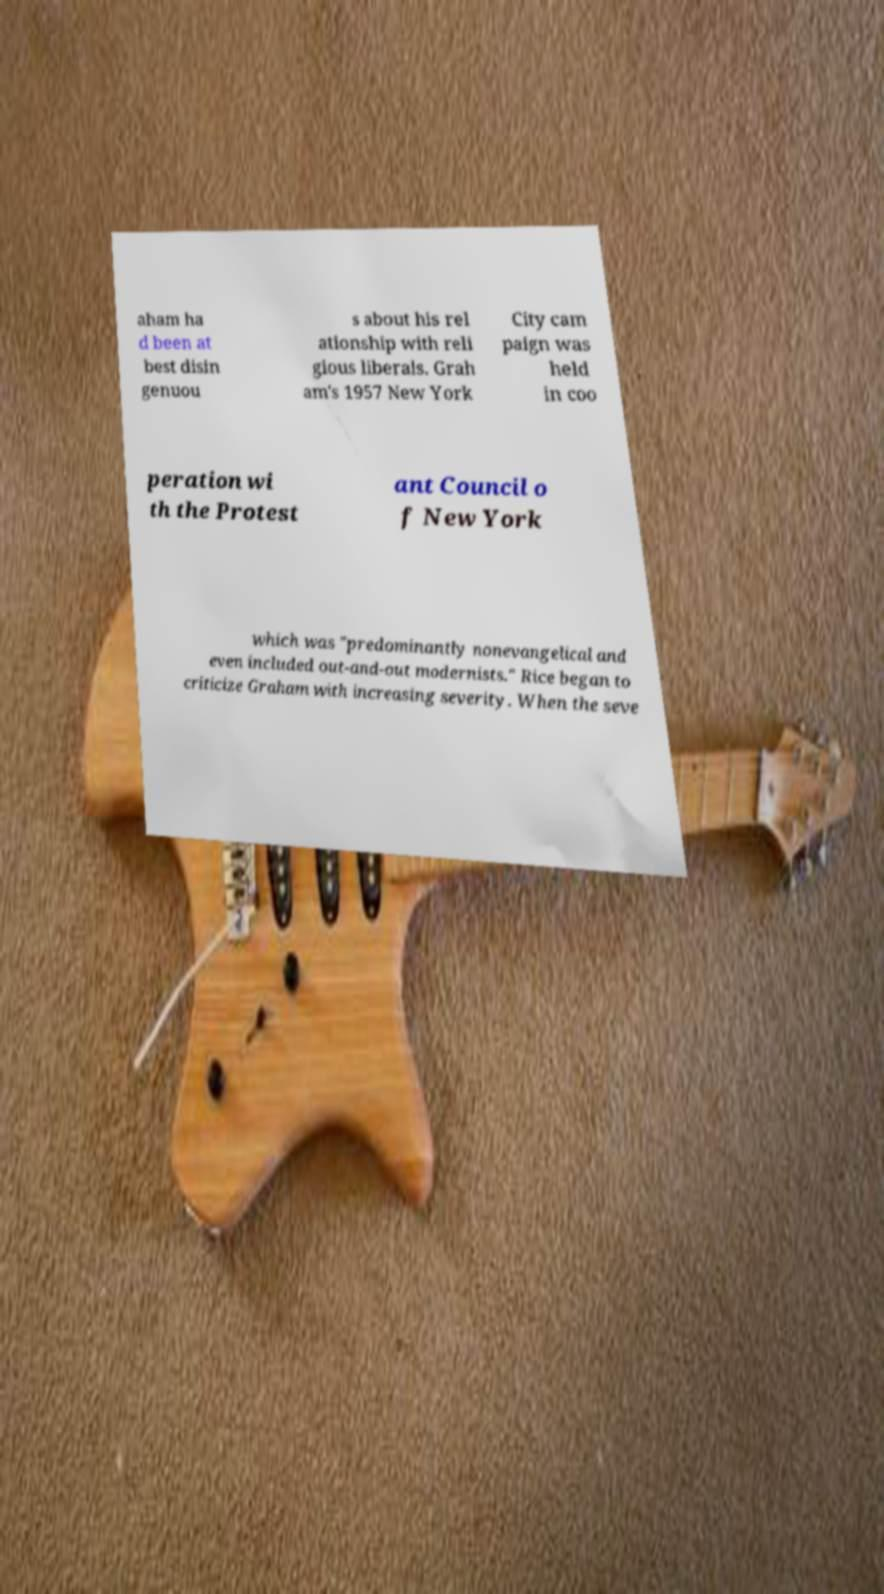Can you accurately transcribe the text from the provided image for me? aham ha d been at best disin genuou s about his rel ationship with reli gious liberals. Grah am's 1957 New York City cam paign was held in coo peration wi th the Protest ant Council o f New York which was "predominantly nonevangelical and even included out-and-out modernists." Rice began to criticize Graham with increasing severity. When the seve 